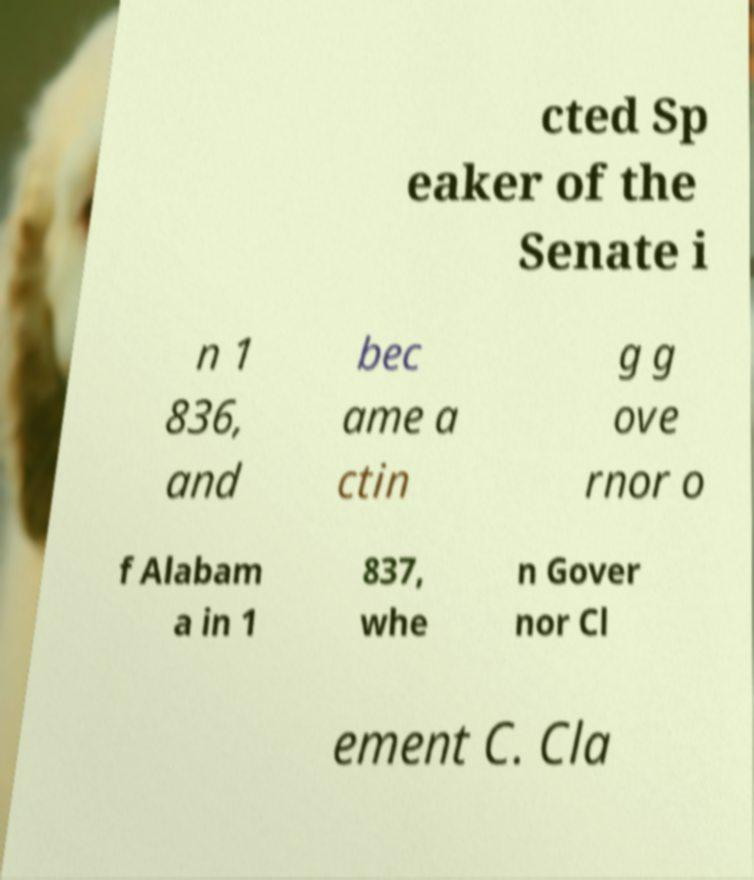For documentation purposes, I need the text within this image transcribed. Could you provide that? cted Sp eaker of the Senate i n 1 836, and bec ame a ctin g g ove rnor o f Alabam a in 1 837, whe n Gover nor Cl ement C. Cla 